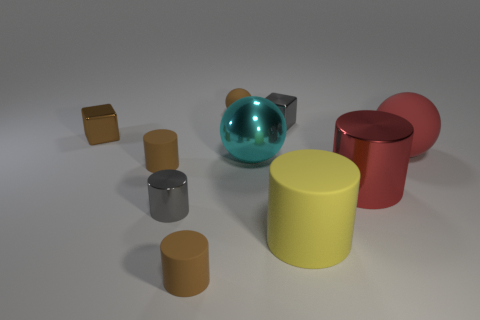Subtract all purple balls. How many brown cylinders are left? 2 Subtract all gray cylinders. How many cylinders are left? 4 Subtract all gray shiny cylinders. How many cylinders are left? 4 Subtract all blue cylinders. Subtract all green cubes. How many cylinders are left? 5 Subtract all blocks. How many objects are left? 8 Add 1 rubber cylinders. How many rubber cylinders are left? 4 Add 3 small brown matte cylinders. How many small brown matte cylinders exist? 5 Subtract 0 purple blocks. How many objects are left? 10 Subtract all small blue metal cylinders. Subtract all brown metal objects. How many objects are left? 9 